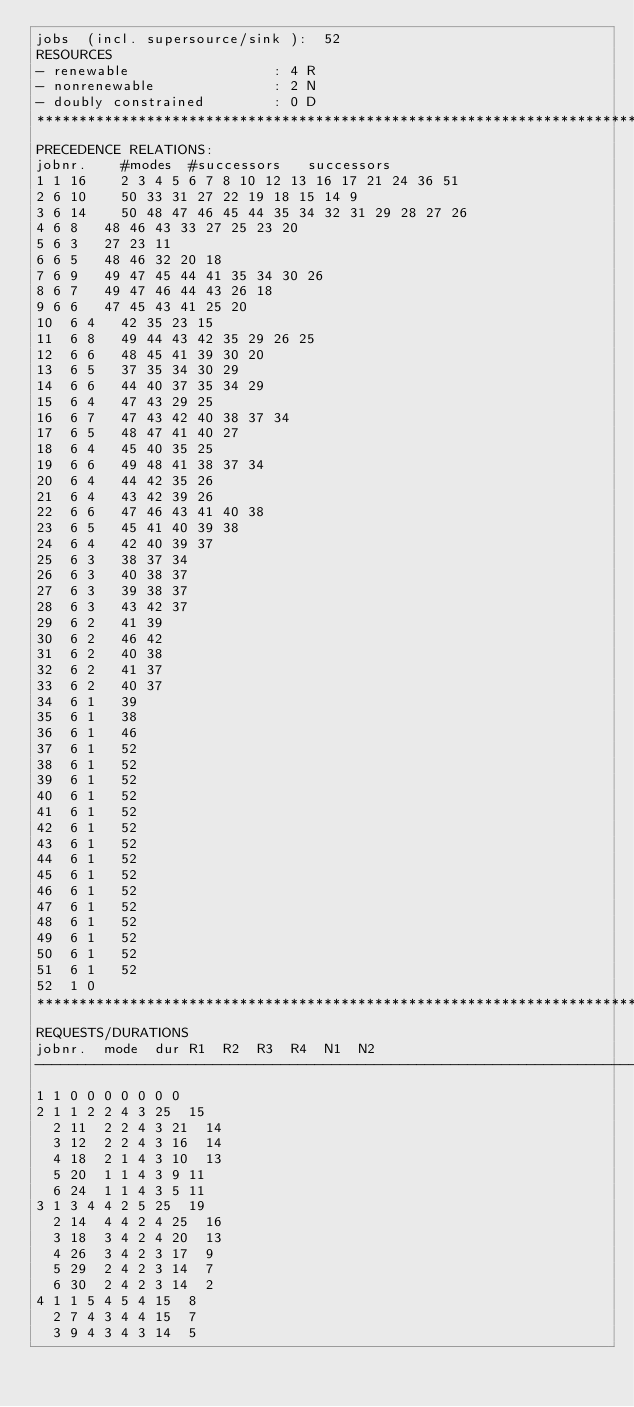<code> <loc_0><loc_0><loc_500><loc_500><_ObjectiveC_>jobs  (incl. supersource/sink ):	52
RESOURCES
- renewable                 : 4 R
- nonrenewable              : 2 N
- doubly constrained        : 0 D
************************************************************************
PRECEDENCE RELATIONS:
jobnr.    #modes  #successors   successors
1	1	16		2 3 4 5 6 7 8 10 12 13 16 17 21 24 36 51 
2	6	10		50 33 31 27 22 19 18 15 14 9 
3	6	14		50 48 47 46 45 44 35 34 32 31 29 28 27 26 
4	6	8		48 46 43 33 27 25 23 20 
5	6	3		27 23 11 
6	6	5		48 46 32 20 18 
7	6	9		49 47 45 44 41 35 34 30 26 
8	6	7		49 47 46 44 43 26 18 
9	6	6		47 45 43 41 25 20 
10	6	4		42 35 23 15 
11	6	8		49 44 43 42 35 29 26 25 
12	6	6		48 45 41 39 30 20 
13	6	5		37 35 34 30 29 
14	6	6		44 40 37 35 34 29 
15	6	4		47 43 29 25 
16	6	7		47 43 42 40 38 37 34 
17	6	5		48 47 41 40 27 
18	6	4		45 40 35 25 
19	6	6		49 48 41 38 37 34 
20	6	4		44 42 35 26 
21	6	4		43 42 39 26 
22	6	6		47 46 43 41 40 38 
23	6	5		45 41 40 39 38 
24	6	4		42 40 39 37 
25	6	3		38 37 34 
26	6	3		40 38 37 
27	6	3		39 38 37 
28	6	3		43 42 37 
29	6	2		41 39 
30	6	2		46 42 
31	6	2		40 38 
32	6	2		41 37 
33	6	2		40 37 
34	6	1		39 
35	6	1		38 
36	6	1		46 
37	6	1		52 
38	6	1		52 
39	6	1		52 
40	6	1		52 
41	6	1		52 
42	6	1		52 
43	6	1		52 
44	6	1		52 
45	6	1		52 
46	6	1		52 
47	6	1		52 
48	6	1		52 
49	6	1		52 
50	6	1		52 
51	6	1		52 
52	1	0		
************************************************************************
REQUESTS/DURATIONS
jobnr.	mode	dur	R1	R2	R3	R4	N1	N2	
------------------------------------------------------------------------
1	1	0	0	0	0	0	0	0	
2	1	1	2	2	4	3	25	15	
	2	11	2	2	4	3	21	14	
	3	12	2	2	4	3	16	14	
	4	18	2	1	4	3	10	13	
	5	20	1	1	4	3	9	11	
	6	24	1	1	4	3	5	11	
3	1	3	4	4	2	5	25	19	
	2	14	4	4	2	4	25	16	
	3	18	3	4	2	4	20	13	
	4	26	3	4	2	3	17	9	
	5	29	2	4	2	3	14	7	
	6	30	2	4	2	3	14	2	
4	1	1	5	4	5	4	15	8	
	2	7	4	3	4	4	15	7	
	3	9	4	3	4	3	14	5	</code> 